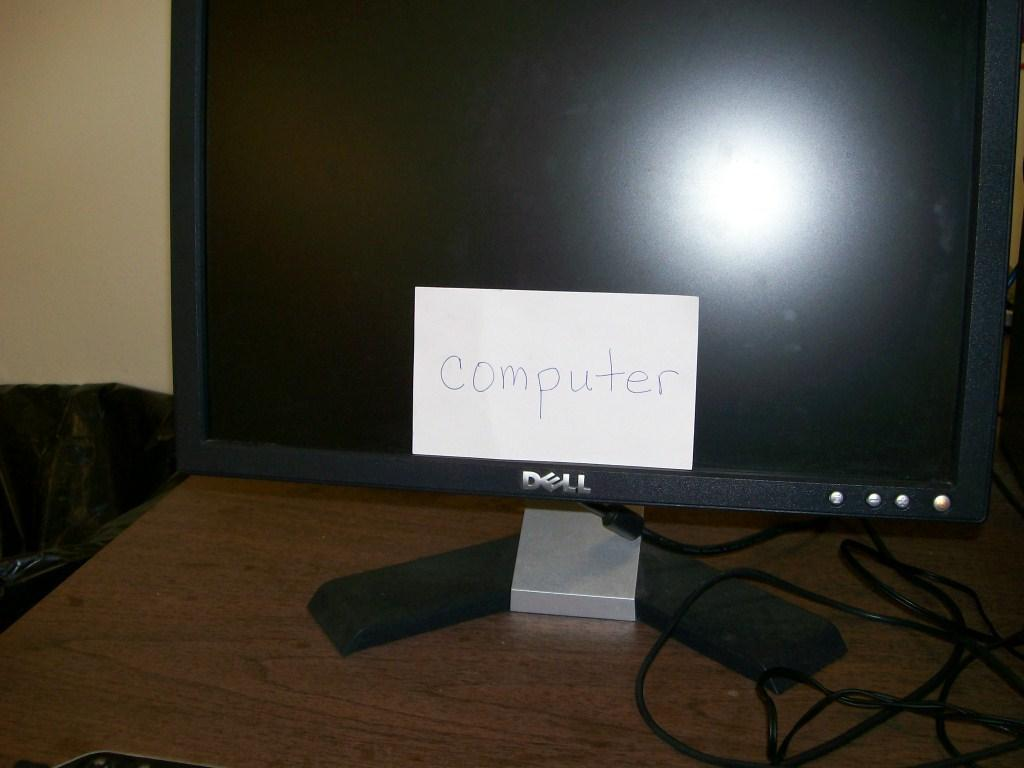<image>
Share a concise interpretation of the image provided. a dell computer with a white note on it that says 'computer' 